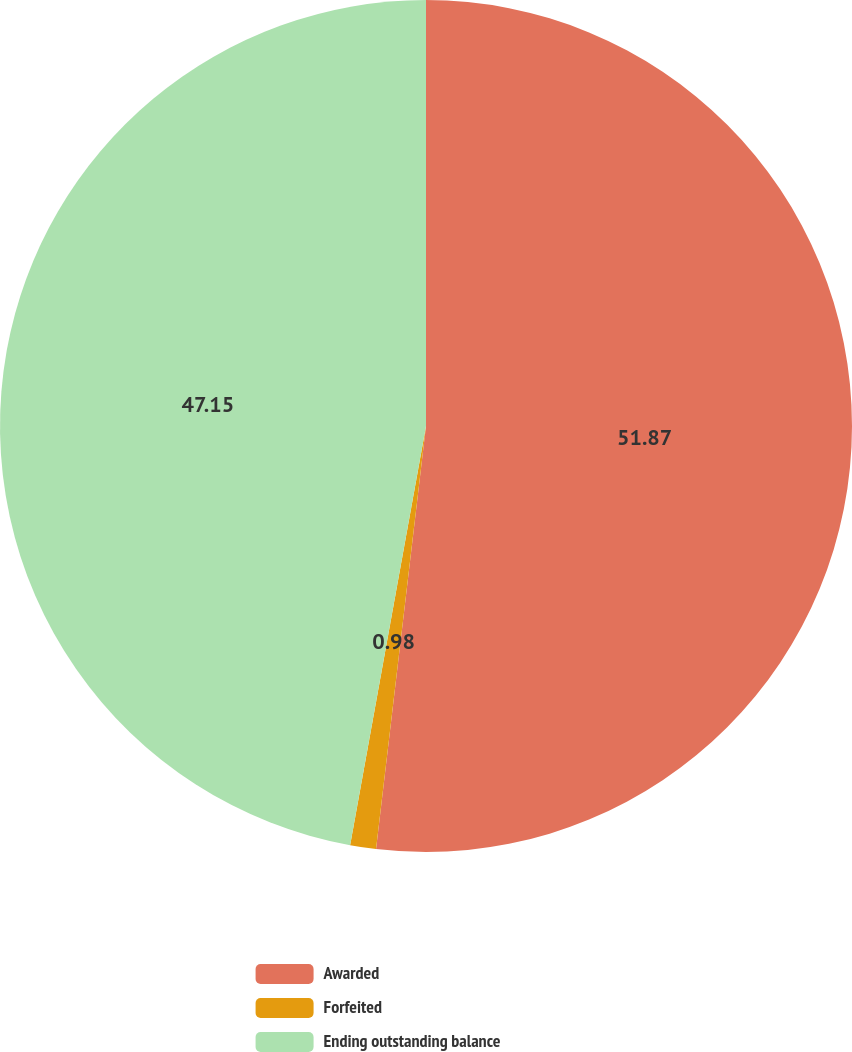Convert chart. <chart><loc_0><loc_0><loc_500><loc_500><pie_chart><fcel>Awarded<fcel>Forfeited<fcel>Ending outstanding balance<nl><fcel>51.87%<fcel>0.98%<fcel>47.15%<nl></chart> 